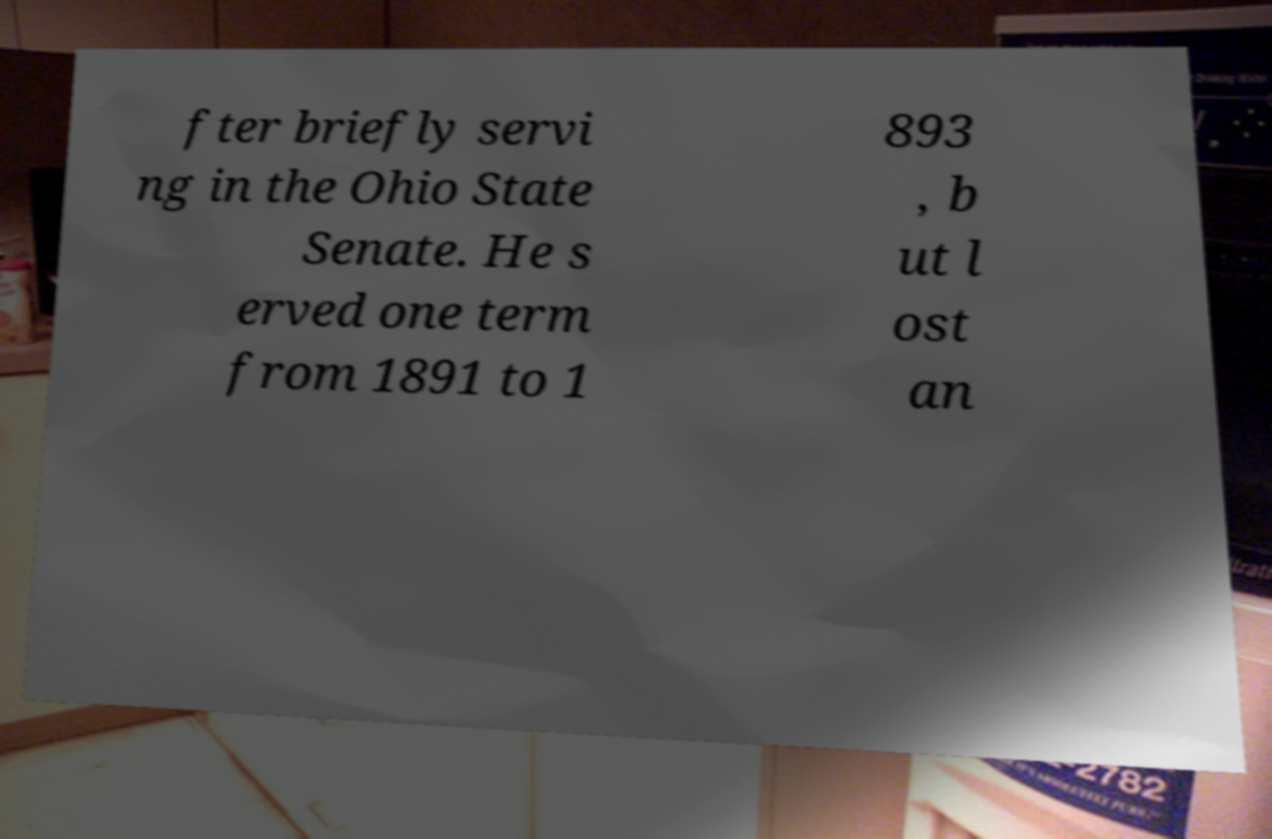For documentation purposes, I need the text within this image transcribed. Could you provide that? fter briefly servi ng in the Ohio State Senate. He s erved one term from 1891 to 1 893 , b ut l ost an 